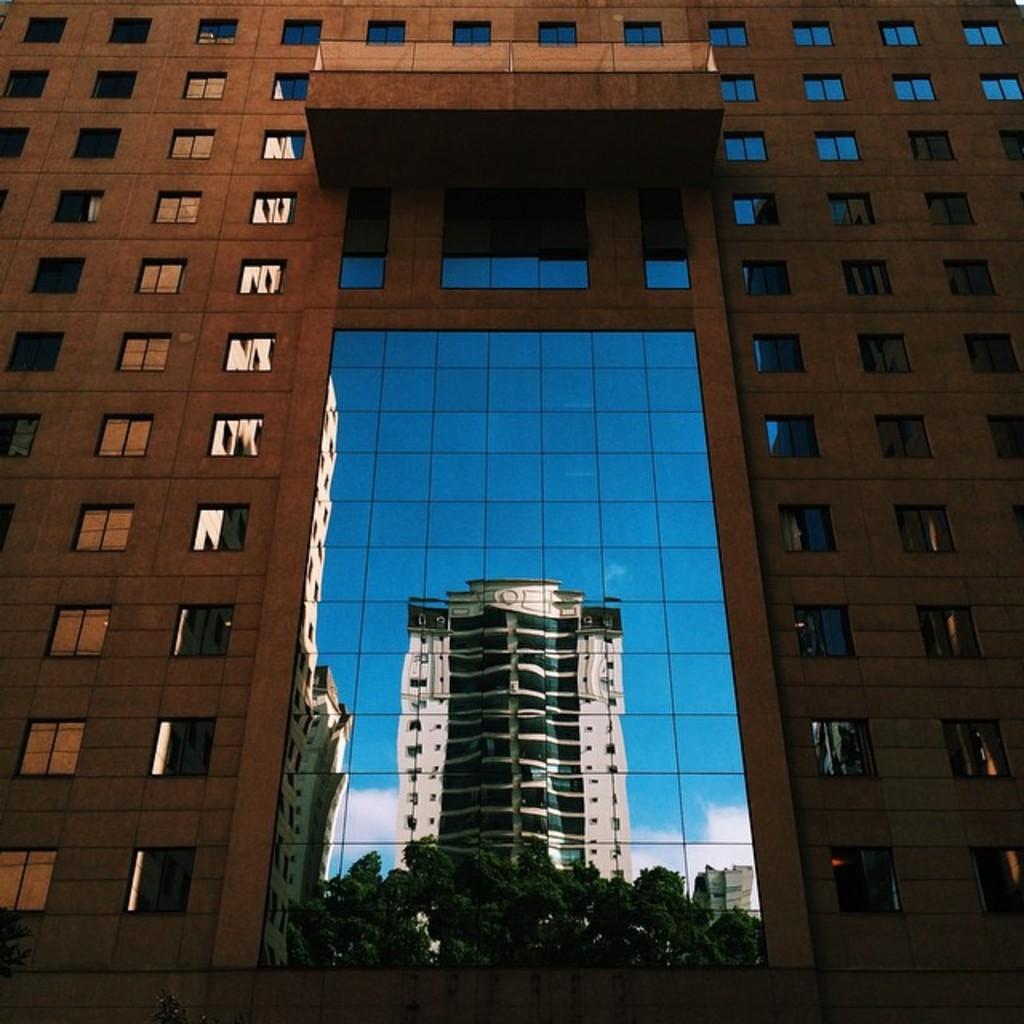In one or two sentences, can you explain what this image depicts? We can see building and glass,through this glass we can see buildings,trees and sky with clouds. 